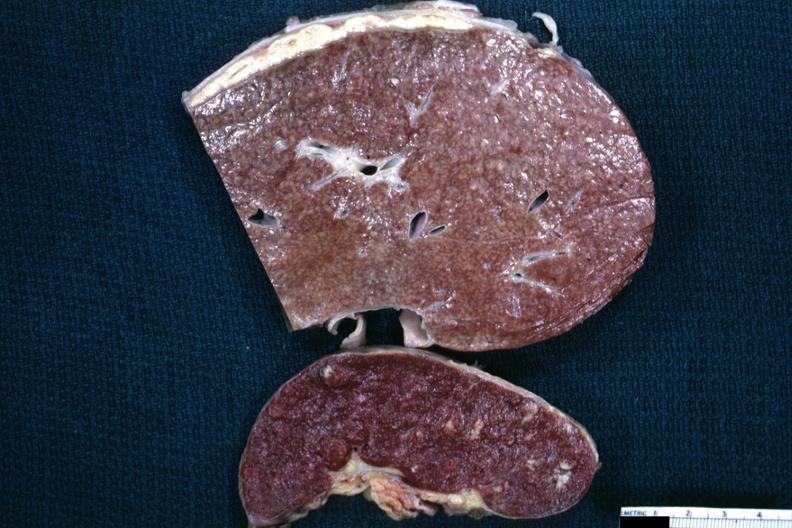s granulomata slide a close-up view of the typical cold abscess exudate on the liver surface?
Answer the question using a single word or phrase. Yes 